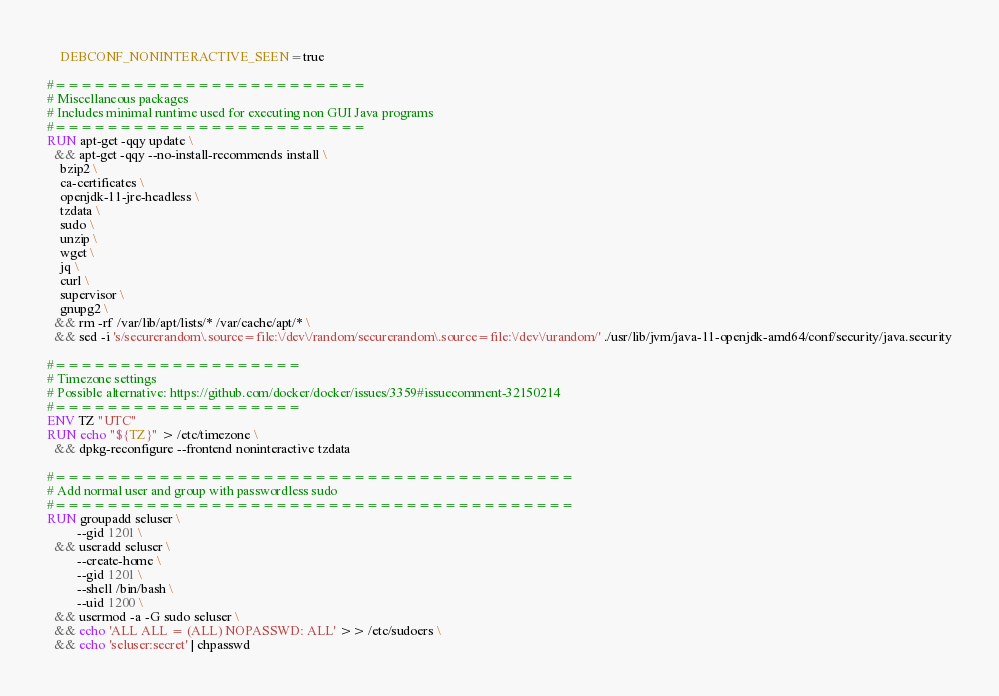Convert code to text. <code><loc_0><loc_0><loc_500><loc_500><_Dockerfile_>    DEBCONF_NONINTERACTIVE_SEEN=true

#========================
# Miscellaneous packages
# Includes minimal runtime used for executing non GUI Java programs
#========================
RUN apt-get -qqy update \
  && apt-get -qqy --no-install-recommends install \
    bzip2 \
    ca-certificates \
    openjdk-11-jre-headless \
    tzdata \
    sudo \
    unzip \
    wget \
    jq \
    curl \
    supervisor \
    gnupg2 \
  && rm -rf /var/lib/apt/lists/* /var/cache/apt/* \
  && sed -i 's/securerandom\.source=file:\/dev\/random/securerandom\.source=file:\/dev\/urandom/' ./usr/lib/jvm/java-11-openjdk-amd64/conf/security/java.security

#===================
# Timezone settings
# Possible alternative: https://github.com/docker/docker/issues/3359#issuecomment-32150214
#===================
ENV TZ "UTC"
RUN echo "${TZ}" > /etc/timezone \
  && dpkg-reconfigure --frontend noninteractive tzdata

#========================================
# Add normal user and group with passwordless sudo
#========================================
RUN groupadd seluser \
         --gid 1201 \
  && useradd seluser \
         --create-home \
         --gid 1201 \
         --shell /bin/bash \
         --uid 1200 \
  && usermod -a -G sudo seluser \
  && echo 'ALL ALL = (ALL) NOPASSWD: ALL' >> /etc/sudoers \
  && echo 'seluser:secret' | chpasswd</code> 